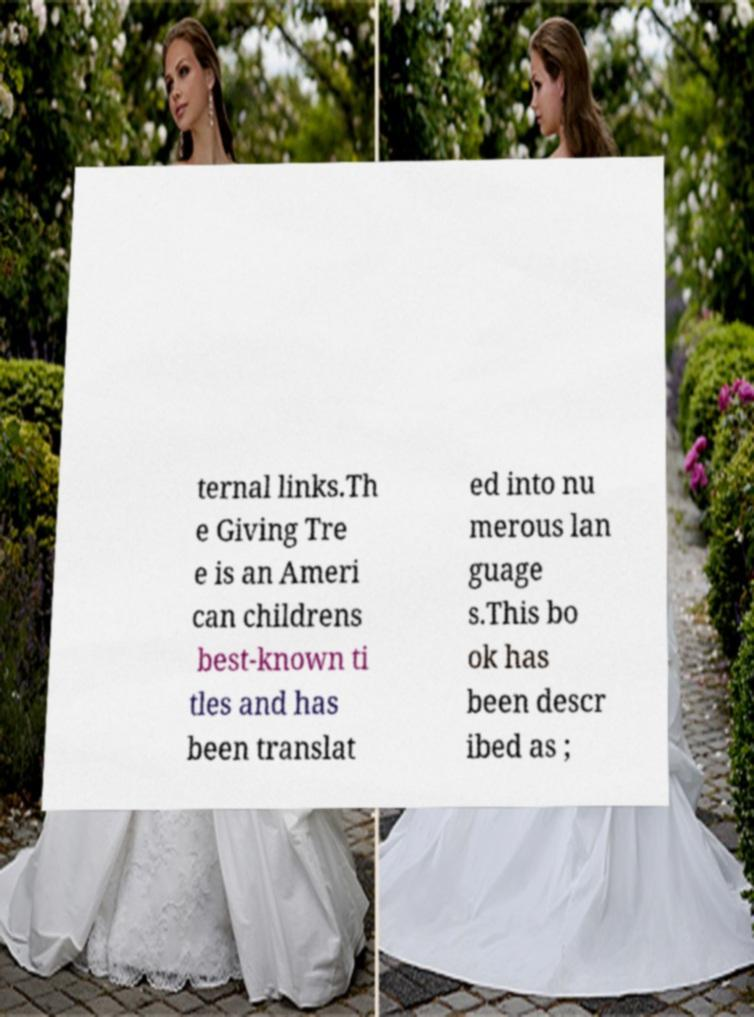I need the written content from this picture converted into text. Can you do that? ternal links.Th e Giving Tre e is an Ameri can childrens best-known ti tles and has been translat ed into nu merous lan guage s.This bo ok has been descr ibed as ; 